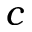<formula> <loc_0><loc_0><loc_500><loc_500>c</formula> 